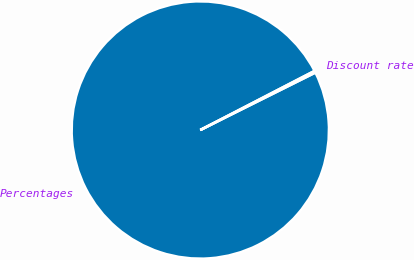Convert chart. <chart><loc_0><loc_0><loc_500><loc_500><pie_chart><fcel>Percentages<fcel>Discount rate<nl><fcel>99.77%<fcel>0.23%<nl></chart> 